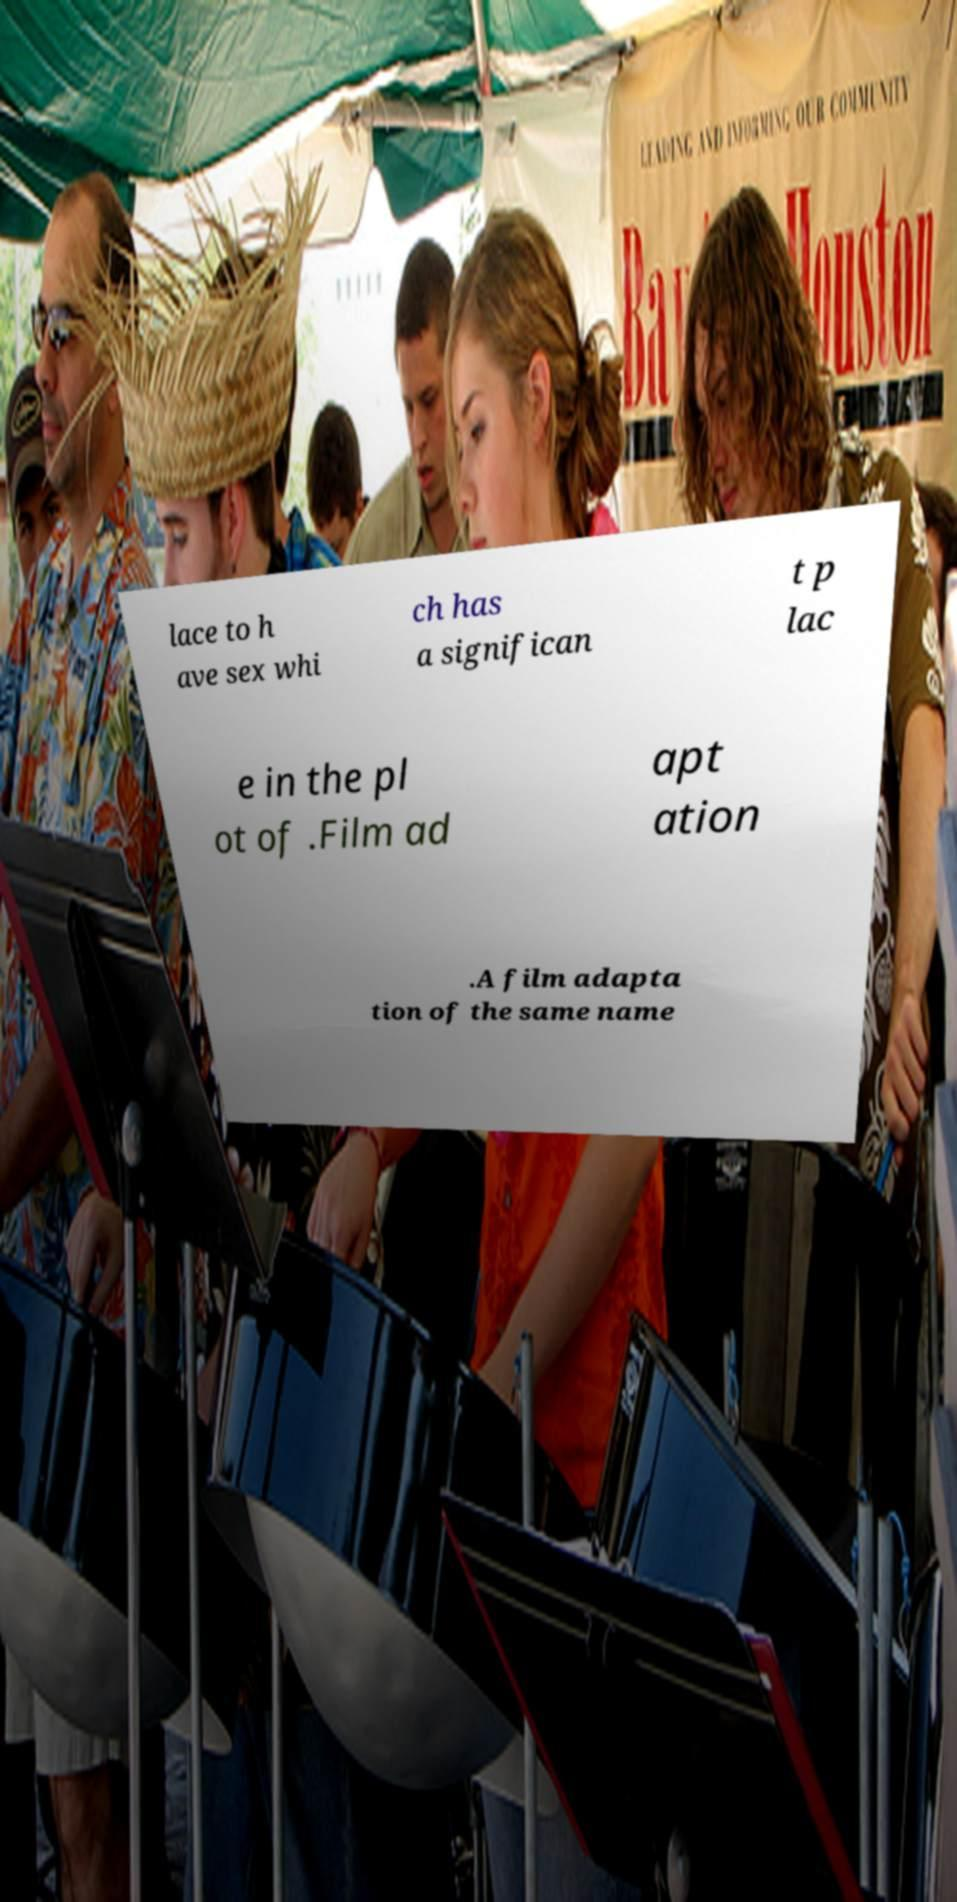For documentation purposes, I need the text within this image transcribed. Could you provide that? lace to h ave sex whi ch has a significan t p lac e in the pl ot of .Film ad apt ation .A film adapta tion of the same name 